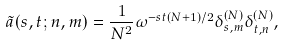Convert formula to latex. <formula><loc_0><loc_0><loc_500><loc_500>\tilde { a } ( s , t ; n , m ) = \frac { 1 } { N ^ { 2 } } \omega ^ { - s t ( N + 1 ) / 2 } \delta ^ { ( N ) } _ { s , m } \delta ^ { ( N ) } _ { t , n } ,</formula> 